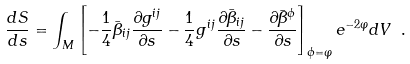Convert formula to latex. <formula><loc_0><loc_0><loc_500><loc_500>\frac { d S } { d s } = \int _ { M } \left [ - \frac { 1 } { 4 } { \bar { \beta } } _ { i j } \frac { \partial g ^ { i j } } { \partial s } - \frac { 1 } { 4 } g ^ { i j } \frac { \partial { \bar { \beta } } _ { i j } } { \partial s } - \frac { \partial { \bar { \beta } } ^ { \phi } } { \partial s } \right ] _ { \phi = \varphi } e ^ { - 2 \varphi } d V \ .</formula> 